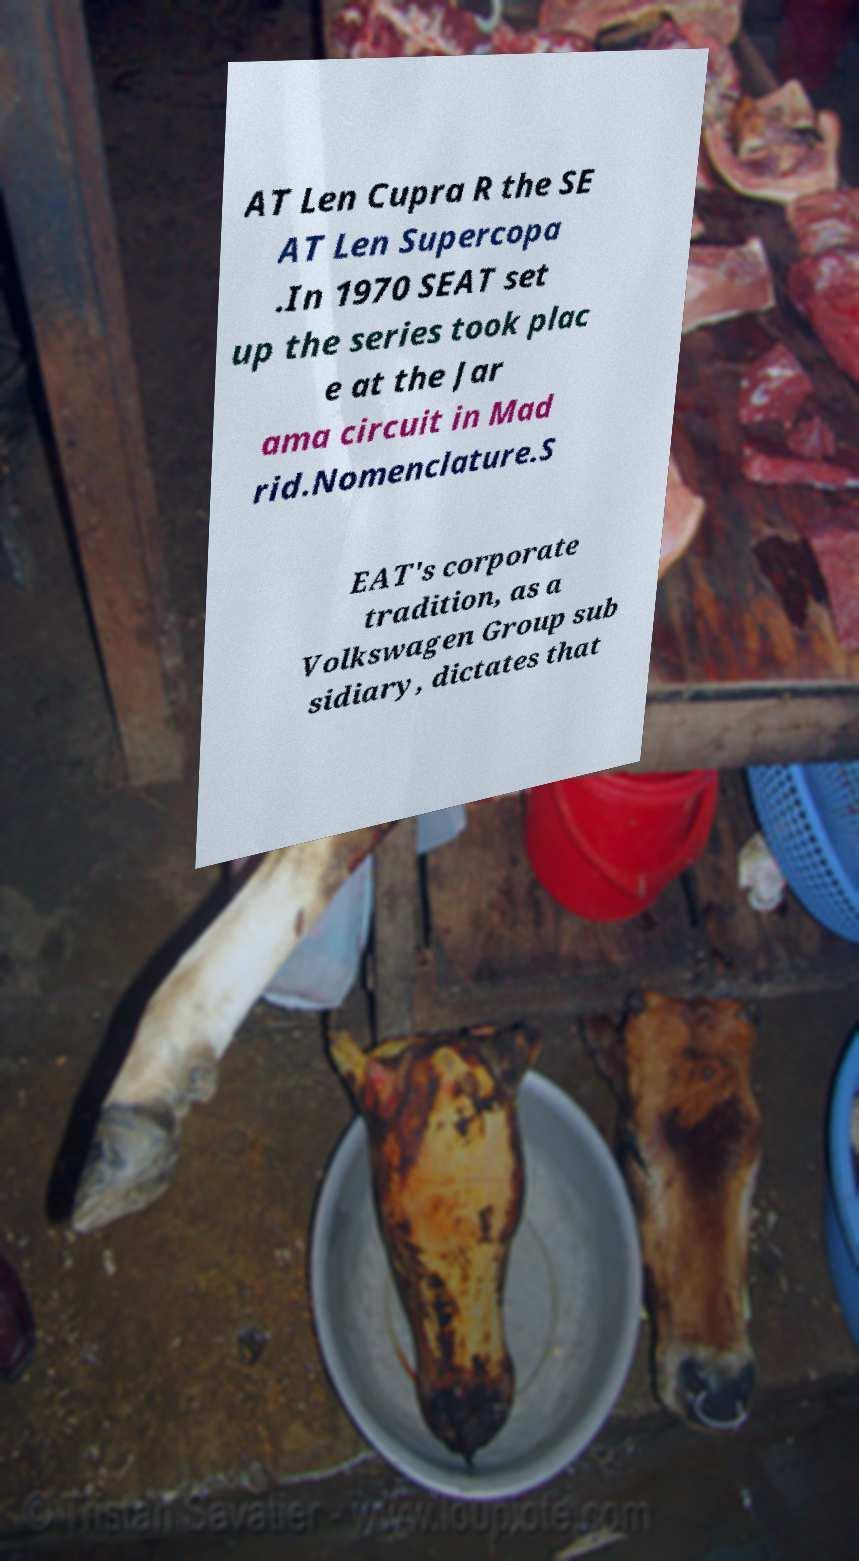Please identify and transcribe the text found in this image. AT Len Cupra R the SE AT Len Supercopa .In 1970 SEAT set up the series took plac e at the Jar ama circuit in Mad rid.Nomenclature.S EAT's corporate tradition, as a Volkswagen Group sub sidiary, dictates that 